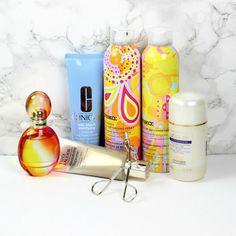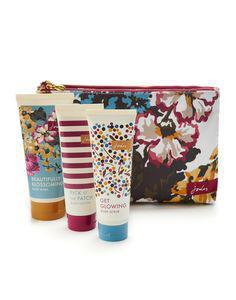The first image is the image on the left, the second image is the image on the right. For the images shown, is this caption "Each image includes products posed with sprig-type things from nature." true? Answer yes or no. No. The first image is the image on the left, the second image is the image on the right. Considering the images on both sides, is "There is a tall bottle with a pump." valid? Answer yes or no. No. 